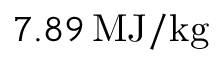<formula> <loc_0><loc_0><loc_500><loc_500>7 . 8 9 \, M J / k g</formula> 